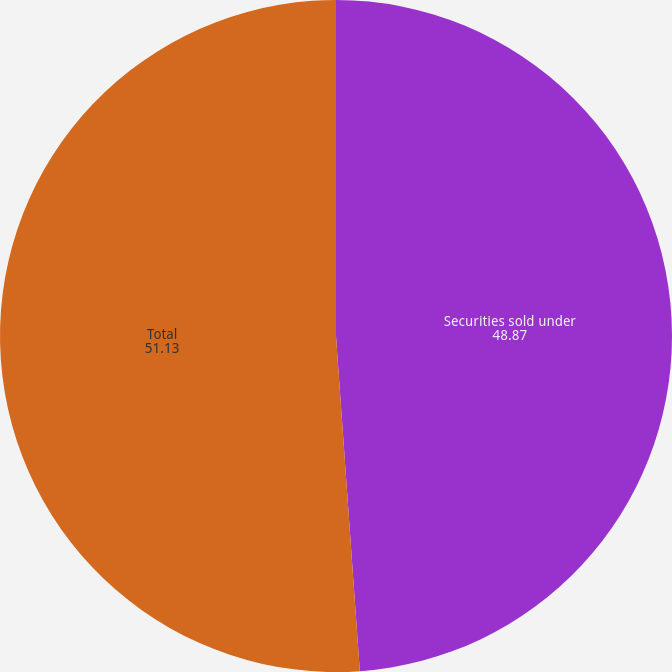Convert chart. <chart><loc_0><loc_0><loc_500><loc_500><pie_chart><fcel>Securities sold under<fcel>Total<nl><fcel>48.87%<fcel>51.13%<nl></chart> 